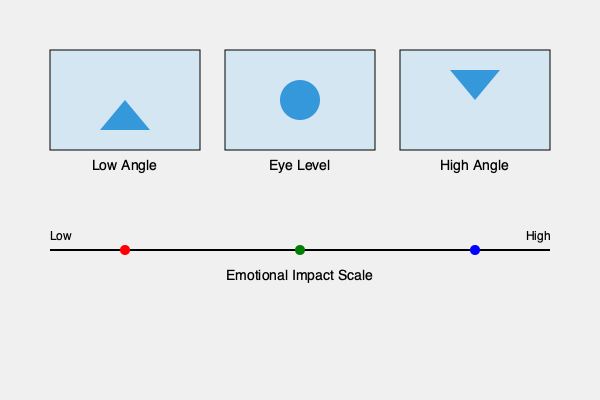Based on the visual representation of different camera angles and their corresponding positions on the emotional impact scale, which camera angle is typically associated with the highest emotional impact in documentary filmmaking, and why might a filmmaker choose this angle for a particular scene? To answer this question, let's analyze the information provided in the graphic:

1. The image shows three common camera angles used in filmmaking: Low Angle, Eye Level, and High Angle.

2. Below these angles, there's an Emotional Impact Scale ranging from Low to High.

3. Each camera angle is represented by a colored dot on the Emotional Impact Scale:
   - Low Angle (red dot): positioned towards the high end of the scale
   - Eye Level (green dot): positioned in the middle of the scale
   - High Angle (blue dot): positioned towards the low end of the scale

4. Based on this representation, the Low Angle shot is associated with the highest emotional impact.

5. Reasons why a filmmaker might choose a low angle shot for high emotional impact:
   a. Power and dominance: Low angle shots make the subject appear larger and more imposing, conveying a sense of power or authority.
   b. Psychological impact: Viewing a subject from below can create feelings of awe, respect, or even fear in the audience.
   c. Emphasizing importance: This angle can make a person or object seem more significant or central to the narrative.
   d. Creating tension: In certain contexts, a low angle can increase dramatic tension or unease.
   e. Perspective shift: It offers a unique viewpoint that can make familiar subjects seem new or different.

6. In documentary filmmaking, a low angle might be used to:
   - Portray a charismatic leader or influential figure
   - Emphasize the grandeur of architecture or natural landscapes
   - Convey the perspective of a child or small animal
   - Highlight the intimidating nature of a situation or environment

The choice of using a low angle shot would depend on the filmmaker's intention, the subject matter, and the emotional response they wish to evoke from the audience.
Answer: Low angle shot; it conveys power, significance, and can create strong emotional responses like awe or tension. 